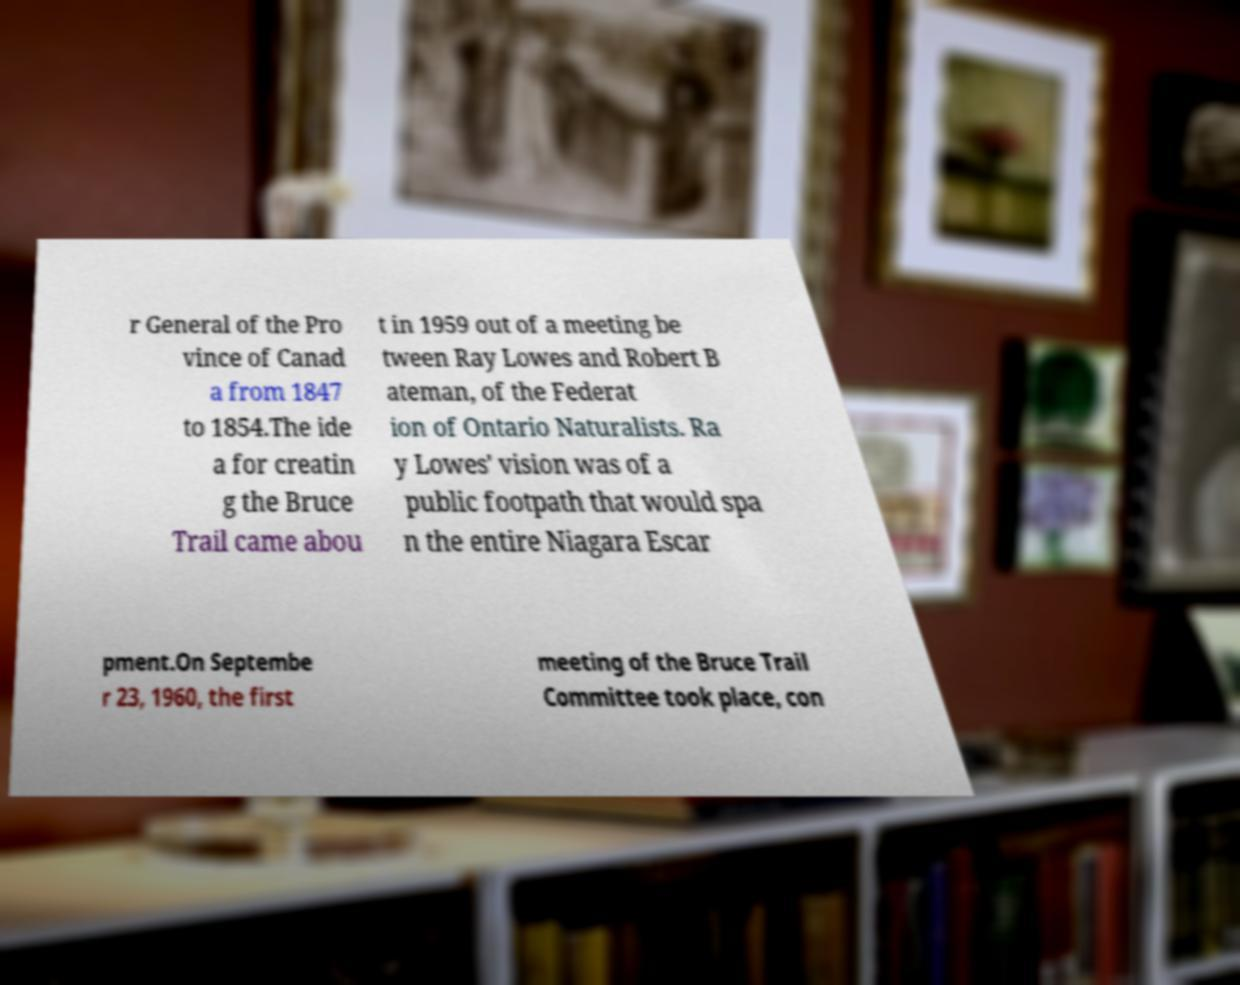I need the written content from this picture converted into text. Can you do that? r General of the Pro vince of Canad a from 1847 to 1854.The ide a for creatin g the Bruce Trail came abou t in 1959 out of a meeting be tween Ray Lowes and Robert B ateman, of the Federat ion of Ontario Naturalists. Ra y Lowes' vision was of a public footpath that would spa n the entire Niagara Escar pment.On Septembe r 23, 1960, the first meeting of the Bruce Trail Committee took place, con 